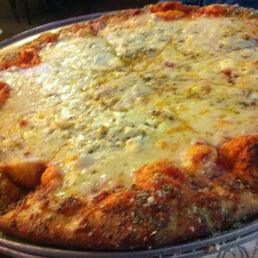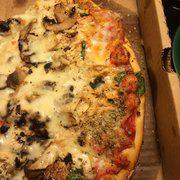The first image is the image on the left, the second image is the image on the right. Analyze the images presented: Is the assertion "The pizza in one of the images is placed on a metal baking pan." valid? Answer yes or no. Yes. 